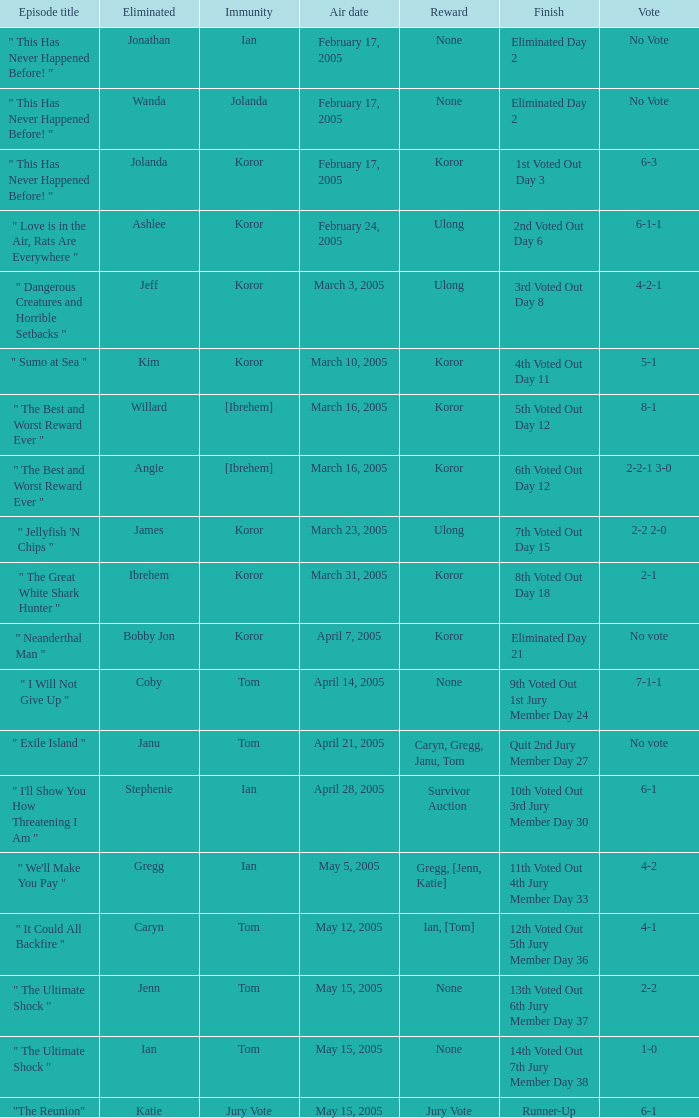Who received the reward on the episode where the finish was "3rd voted out day 8"? Ulong. 